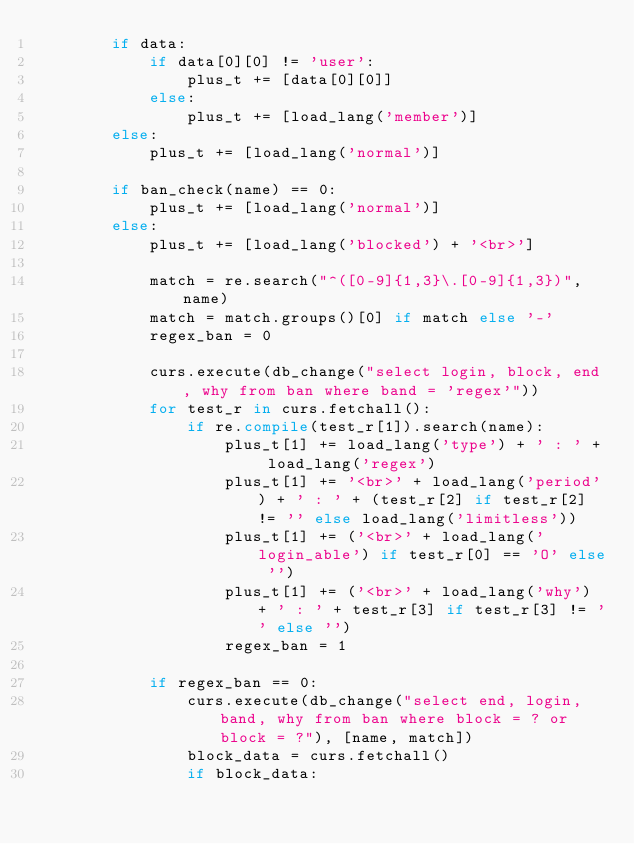Convert code to text. <code><loc_0><loc_0><loc_500><loc_500><_Python_>        if data:
            if data[0][0] != 'user':
                plus_t += [data[0][0]]
            else:
                plus_t += [load_lang('member')]
        else:
            plus_t += [load_lang('normal')]

        if ban_check(name) == 0:
            plus_t += [load_lang('normal')]
        else:
            plus_t += [load_lang('blocked') + '<br>']

            match = re.search("^([0-9]{1,3}\.[0-9]{1,3})", name)
            match = match.groups()[0] if match else '-'
            regex_ban = 0

            curs.execute(db_change("select login, block, end, why from ban where band = 'regex'"))
            for test_r in curs.fetchall():
                if re.compile(test_r[1]).search(name):
                    plus_t[1] += load_lang('type') + ' : ' + load_lang('regex')
                    plus_t[1] += '<br>' + load_lang('period') + ' : ' + (test_r[2] if test_r[2] != '' else load_lang('limitless'))
                    plus_t[1] += ('<br>' + load_lang('login_able') if test_r[0] == 'O' else '')
                    plus_t[1] += ('<br>' + load_lang('why') + ' : ' + test_r[3] if test_r[3] != '' else '')
                    regex_ban = 1

            if regex_ban == 0:
                curs.execute(db_change("select end, login, band, why from ban where block = ? or block = ?"), [name, match])
                block_data = curs.fetchall()
                if block_data:</code> 